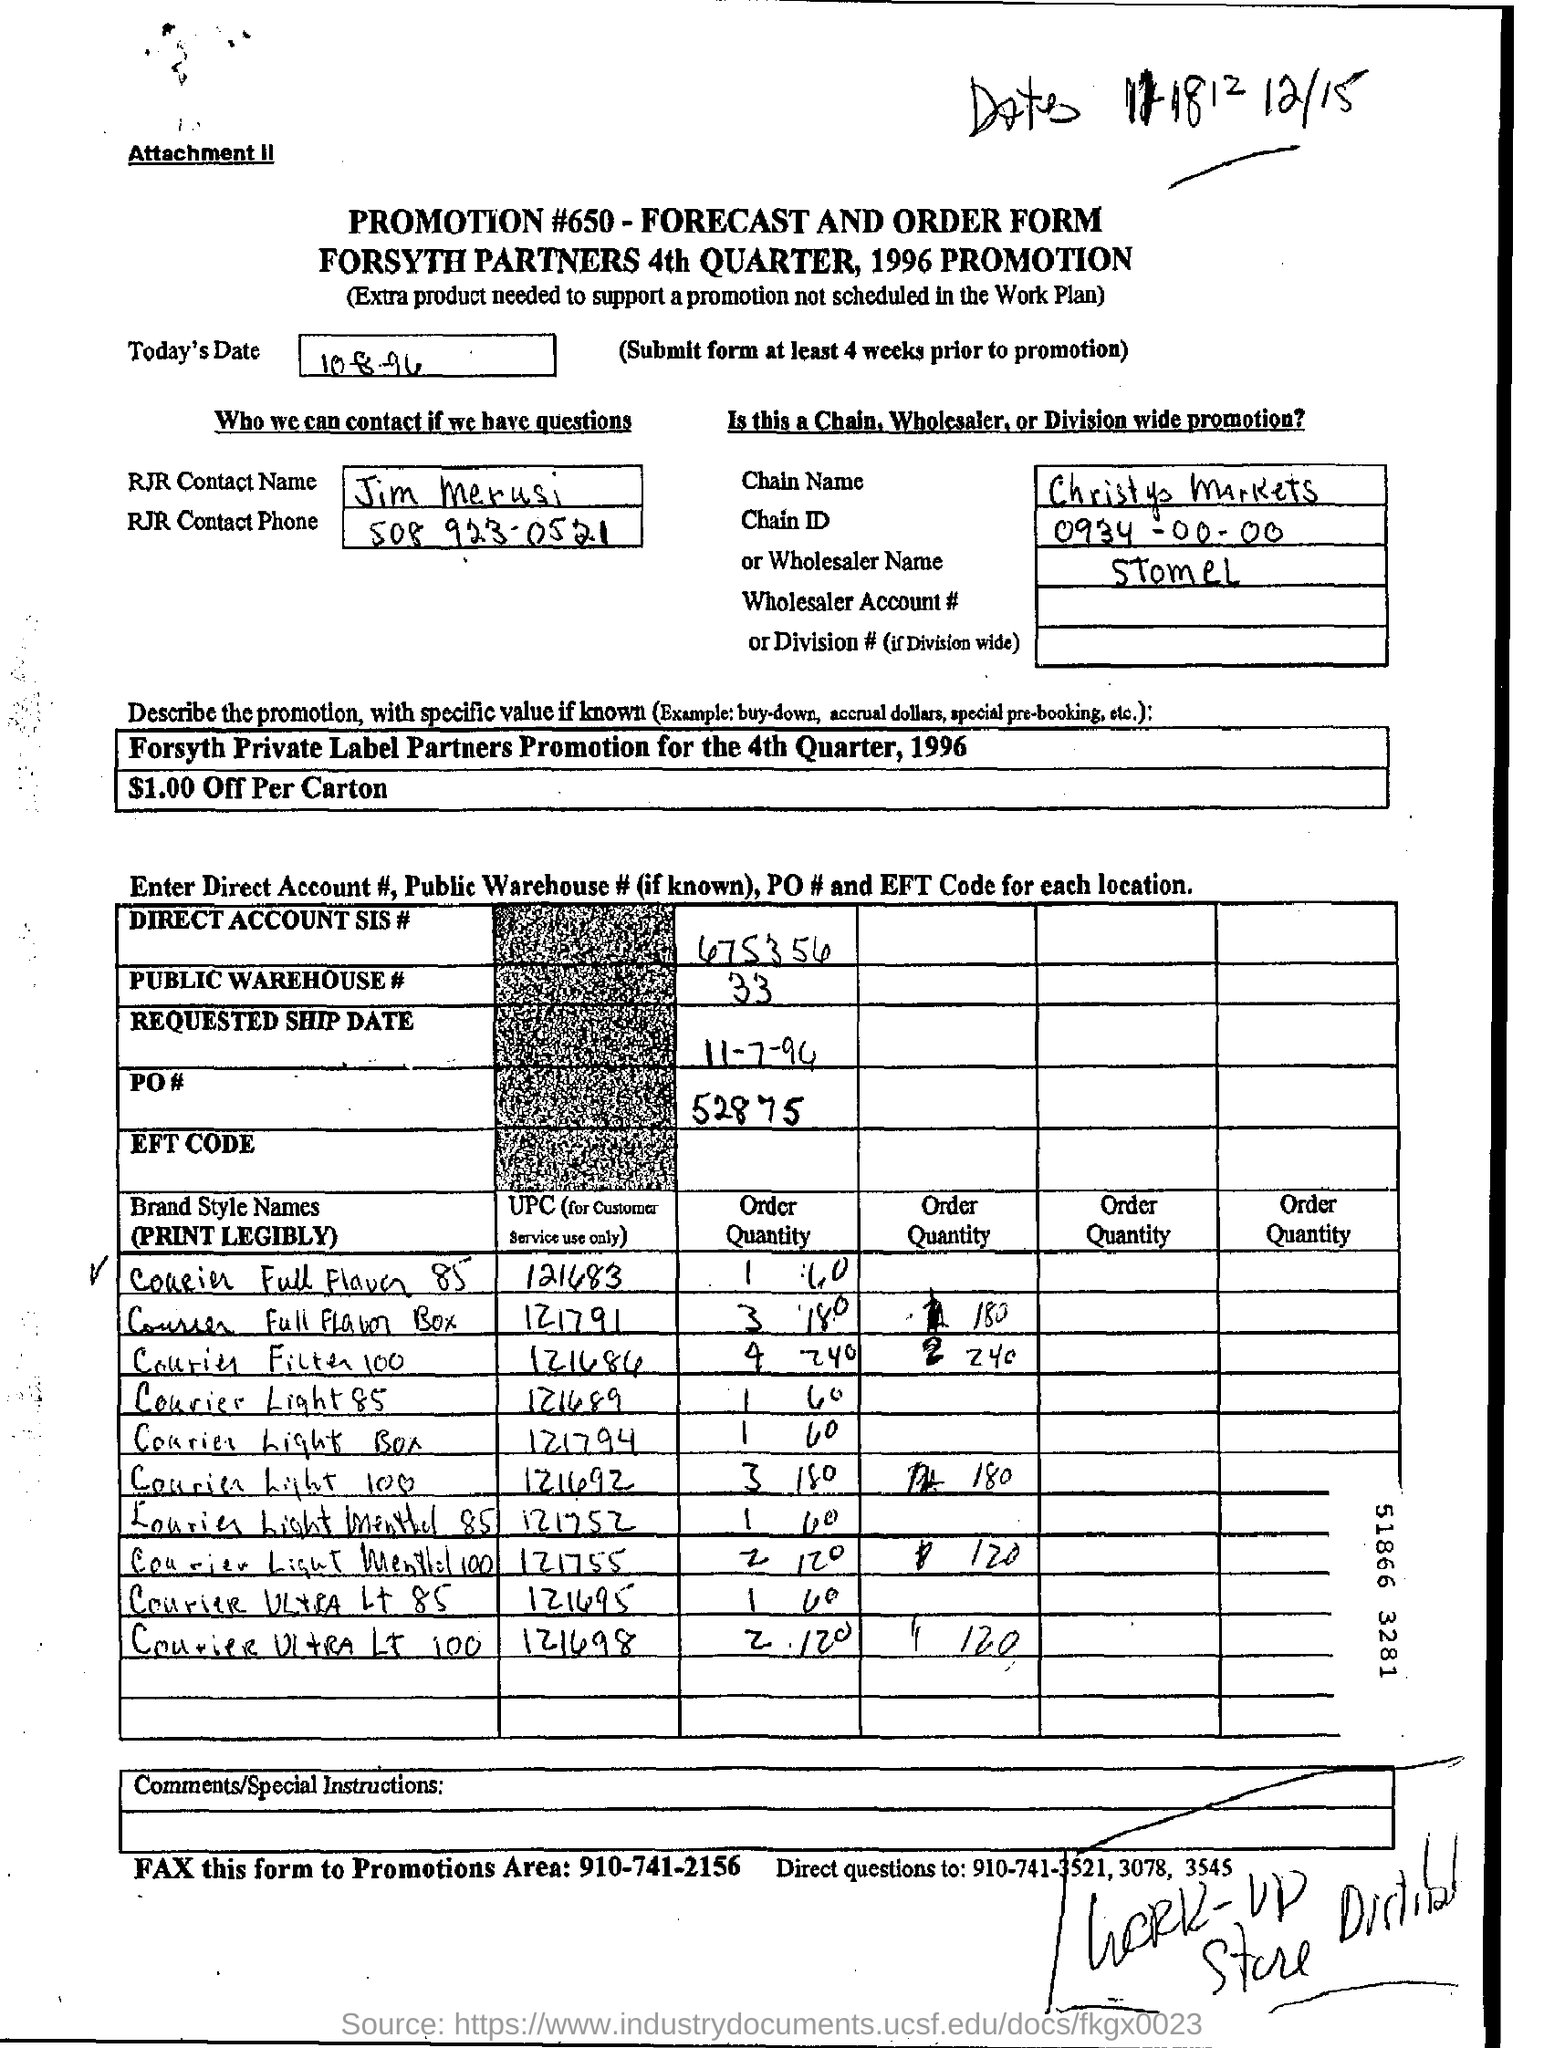When is the document dated?
Give a very brief answer. 10-8-96. Who to contact in case of questions?
Provide a short and direct response. Jim Merusi. 